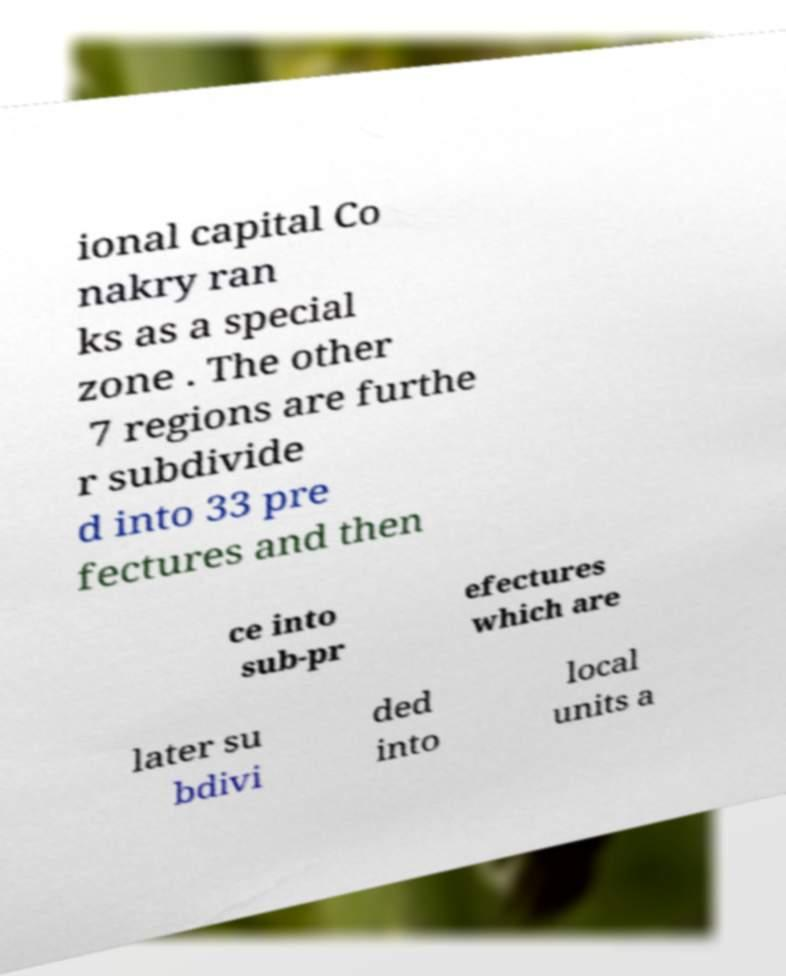Could you extract and type out the text from this image? ional capital Co nakry ran ks as a special zone . The other 7 regions are furthe r subdivide d into 33 pre fectures and then ce into sub-pr efectures which are later su bdivi ded into local units a 